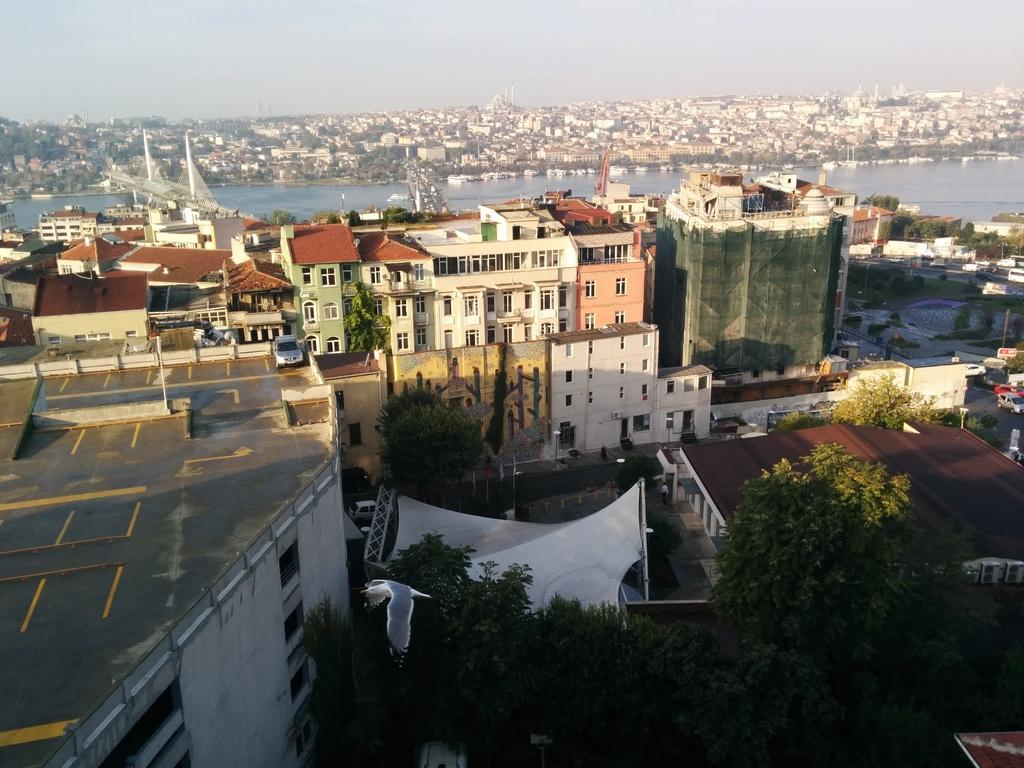What type of structures can be seen in the image? There are buildings in the image. What natural elements are present in the image? There are trees in the image. What man-made objects can be seen in the image? There are vehicles and poles in the image. What is the purpose of the poles in the image? The poles appear to be bridges in the image. What is the water visible in the image? The water is visible in the image. What is visible in the background of the image? The sky is visible in the background of the image. What type of straw is being used to build the rail in the image? There is no rail or straw present in the image. How does the sea affect the buildings in the image? There is no sea present in the image; it features buildings, trees, vehicles, poles, water, and the sky. 